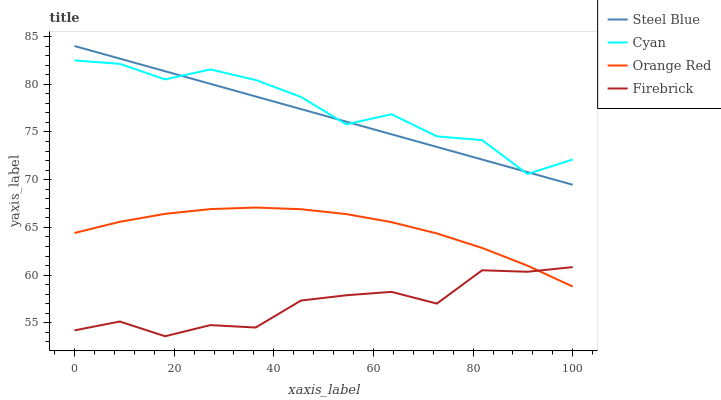Does Firebrick have the minimum area under the curve?
Answer yes or no. Yes. Does Cyan have the maximum area under the curve?
Answer yes or no. Yes. Does Steel Blue have the minimum area under the curve?
Answer yes or no. No. Does Steel Blue have the maximum area under the curve?
Answer yes or no. No. Is Steel Blue the smoothest?
Answer yes or no. Yes. Is Cyan the roughest?
Answer yes or no. Yes. Is Firebrick the smoothest?
Answer yes or no. No. Is Firebrick the roughest?
Answer yes or no. No. Does Steel Blue have the lowest value?
Answer yes or no. No. Does Steel Blue have the highest value?
Answer yes or no. Yes. Does Firebrick have the highest value?
Answer yes or no. No. Is Orange Red less than Cyan?
Answer yes or no. Yes. Is Steel Blue greater than Orange Red?
Answer yes or no. Yes. Does Orange Red intersect Firebrick?
Answer yes or no. Yes. Is Orange Red less than Firebrick?
Answer yes or no. No. Is Orange Red greater than Firebrick?
Answer yes or no. No. Does Orange Red intersect Cyan?
Answer yes or no. No. 